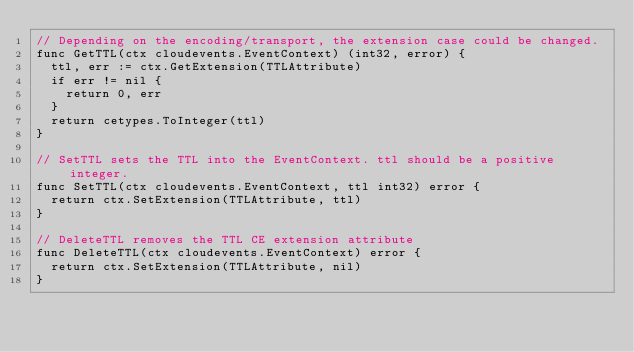<code> <loc_0><loc_0><loc_500><loc_500><_Go_>// Depending on the encoding/transport, the extension case could be changed.
func GetTTL(ctx cloudevents.EventContext) (int32, error) {
	ttl, err := ctx.GetExtension(TTLAttribute)
	if err != nil {
		return 0, err
	}
	return cetypes.ToInteger(ttl)
}

// SetTTL sets the TTL into the EventContext. ttl should be a positive integer.
func SetTTL(ctx cloudevents.EventContext, ttl int32) error {
	return ctx.SetExtension(TTLAttribute, ttl)
}

// DeleteTTL removes the TTL CE extension attribute
func DeleteTTL(ctx cloudevents.EventContext) error {
	return ctx.SetExtension(TTLAttribute, nil)
}
</code> 